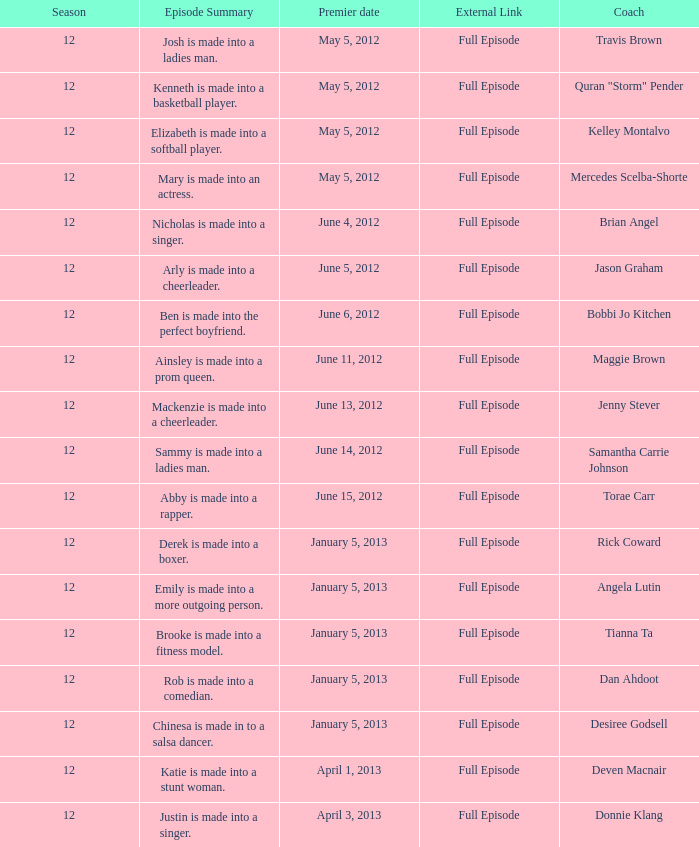What is the episode summary for travis brown? Josh is made into a ladies man. 